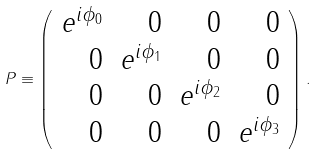Convert formula to latex. <formula><loc_0><loc_0><loc_500><loc_500>P \equiv \left ( \begin{array} { r r r r } e ^ { i \phi _ { 0 } } & 0 & 0 & 0 \\ 0 & e ^ { i \phi _ { 1 } } & 0 & 0 \\ 0 & 0 & e ^ { i \phi _ { 2 } } & 0 \\ 0 & 0 & 0 & e ^ { i \phi _ { 3 } } \end{array} \right ) .</formula> 